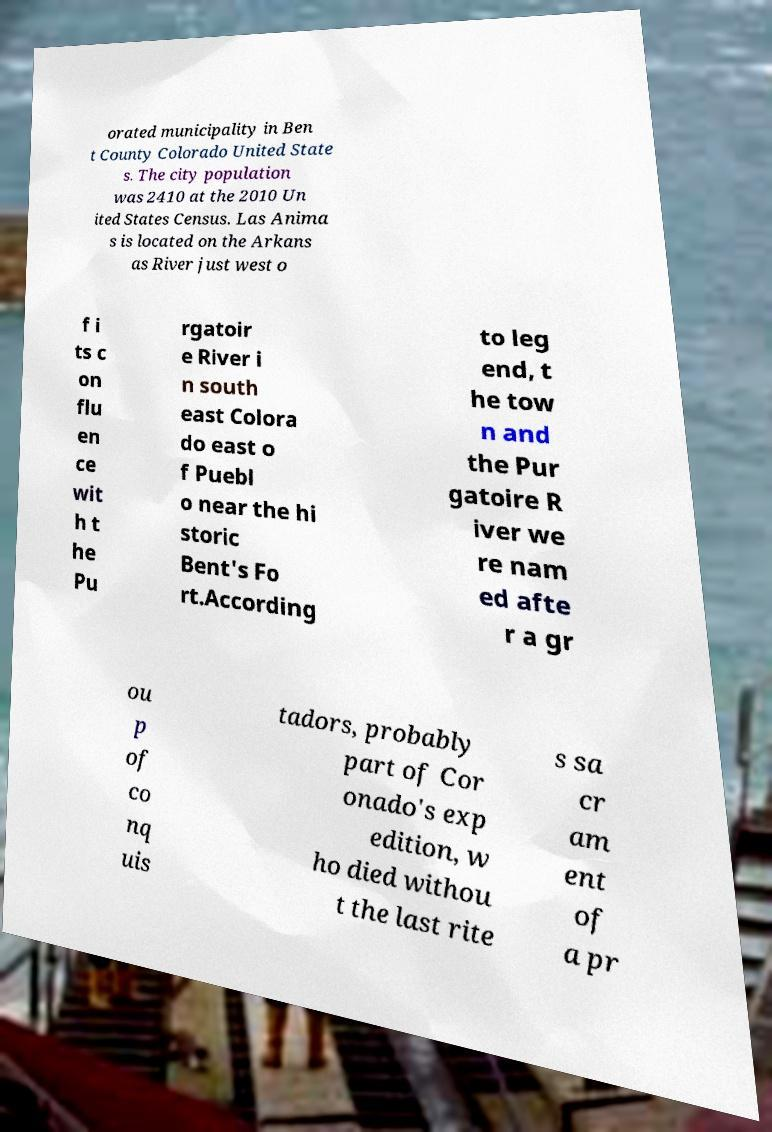Could you extract and type out the text from this image? orated municipality in Ben t County Colorado United State s. The city population was 2410 at the 2010 Un ited States Census. Las Anima s is located on the Arkans as River just west o f i ts c on flu en ce wit h t he Pu rgatoir e River i n south east Colora do east o f Puebl o near the hi storic Bent's Fo rt.According to leg end, t he tow n and the Pur gatoire R iver we re nam ed afte r a gr ou p of co nq uis tadors, probably part of Cor onado's exp edition, w ho died withou t the last rite s sa cr am ent of a pr 